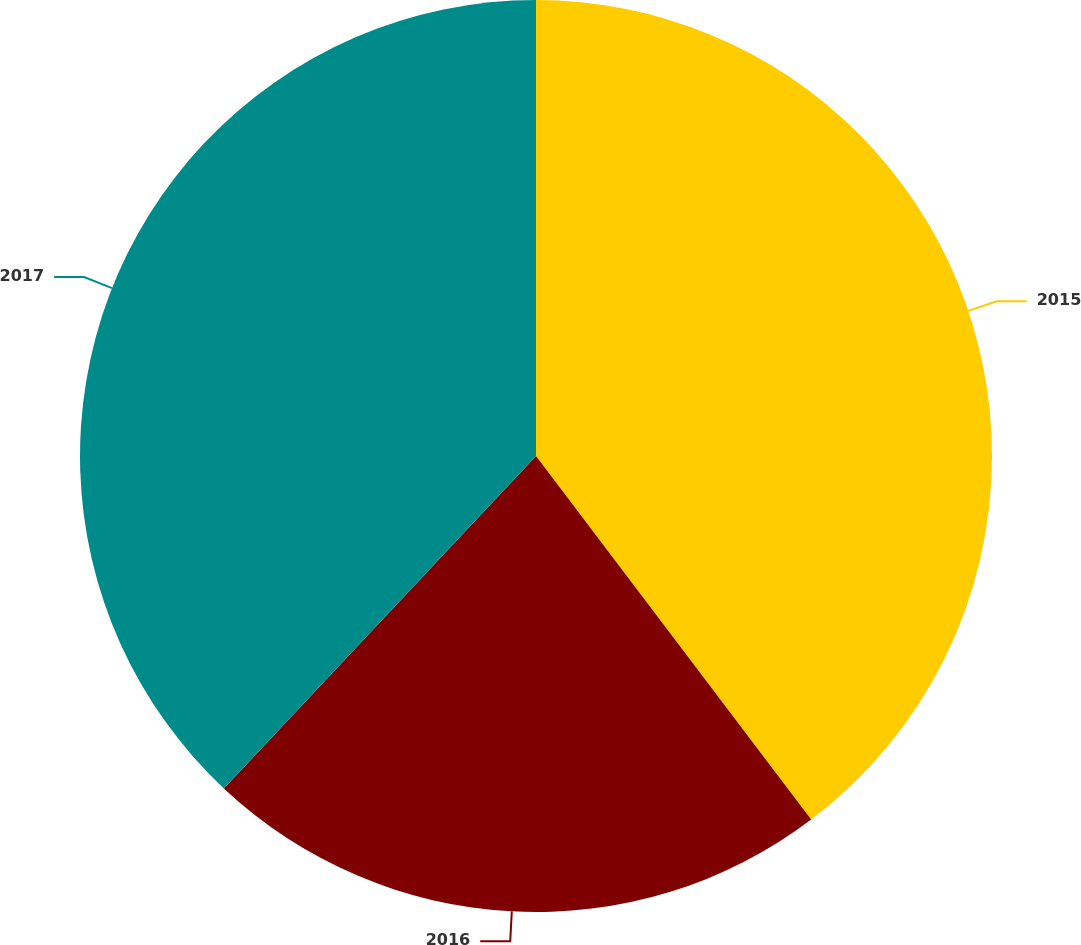Convert chart to OTSL. <chart><loc_0><loc_0><loc_500><loc_500><pie_chart><fcel>2015<fcel>2016<fcel>2017<nl><fcel>39.69%<fcel>22.31%<fcel>38.0%<nl></chart> 